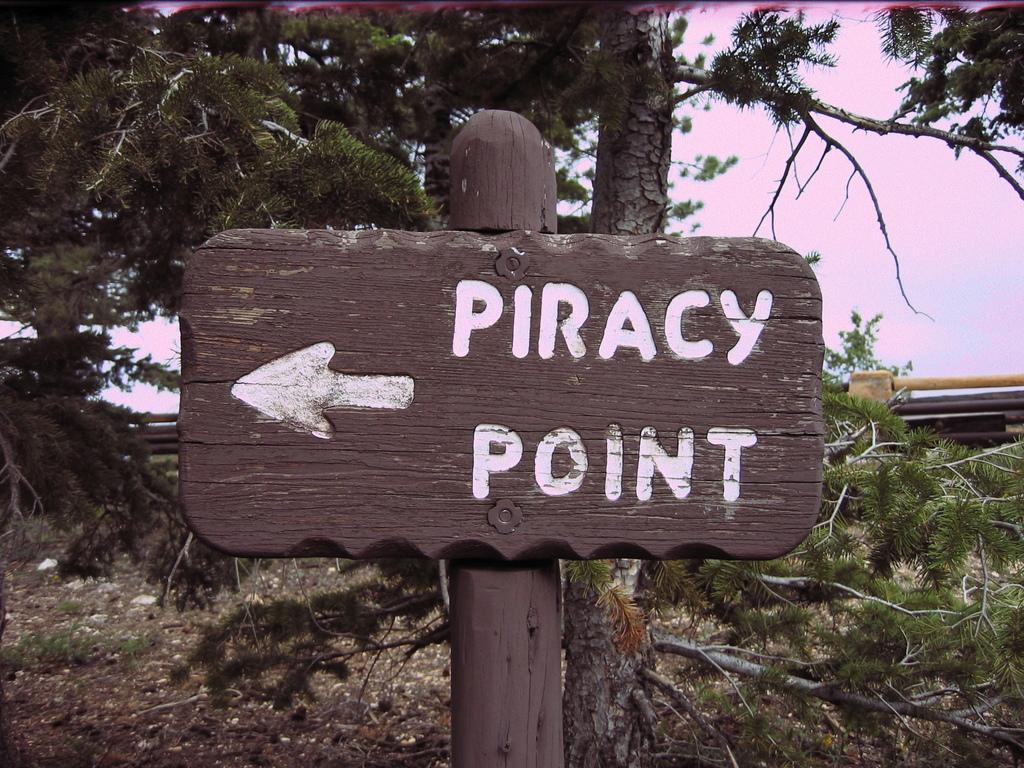Please provide a concise description of this image. In this image, we can see a wooden pole with some text written on it. In the background, we can see some trees and the sky. 